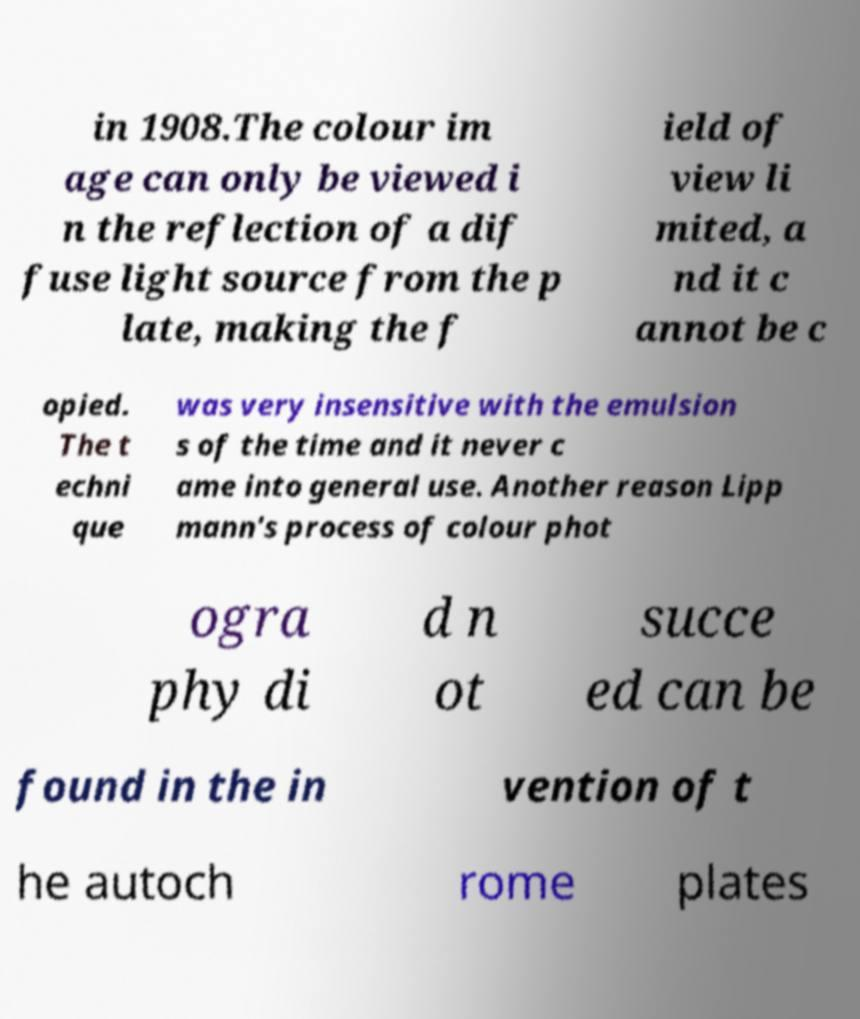Please read and relay the text visible in this image. What does it say? in 1908.The colour im age can only be viewed i n the reflection of a dif fuse light source from the p late, making the f ield of view li mited, a nd it c annot be c opied. The t echni que was very insensitive with the emulsion s of the time and it never c ame into general use. Another reason Lipp mann's process of colour phot ogra phy di d n ot succe ed can be found in the in vention of t he autoch rome plates 